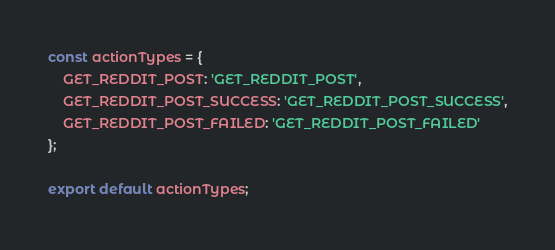Convert code to text. <code><loc_0><loc_0><loc_500><loc_500><_JavaScript_>const actionTypes = {
    GET_REDDIT_POST: 'GET_REDDIT_POST',
    GET_REDDIT_POST_SUCCESS: 'GET_REDDIT_POST_SUCCESS',
    GET_REDDIT_POST_FAILED: 'GET_REDDIT_POST_FAILED'
};

export default actionTypes;</code> 